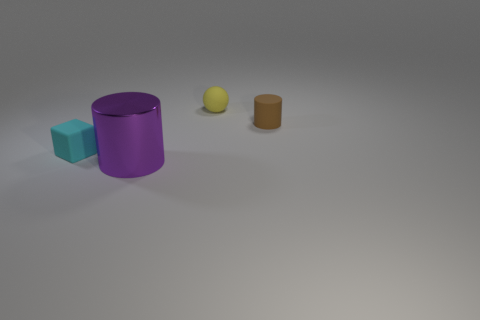Subtract 1 spheres. How many spheres are left? 0 Subtract all spheres. How many objects are left? 3 Add 4 large metal cylinders. How many large metal cylinders exist? 5 Add 4 big brown rubber blocks. How many objects exist? 8 Subtract all brown cylinders. How many cylinders are left? 1 Subtract 0 yellow blocks. How many objects are left? 4 Subtract all green cubes. Subtract all purple cylinders. How many cubes are left? 1 Subtract all gray cubes. How many brown cylinders are left? 1 Subtract all big red matte objects. Subtract all small yellow matte objects. How many objects are left? 3 Add 4 cyan rubber blocks. How many cyan rubber blocks are left? 5 